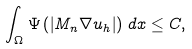<formula> <loc_0><loc_0><loc_500><loc_500>\int _ { \Omega } \Psi \left ( \left | M _ { n } \nabla u _ { h } \right | \right ) \, d x \leq C ,</formula> 